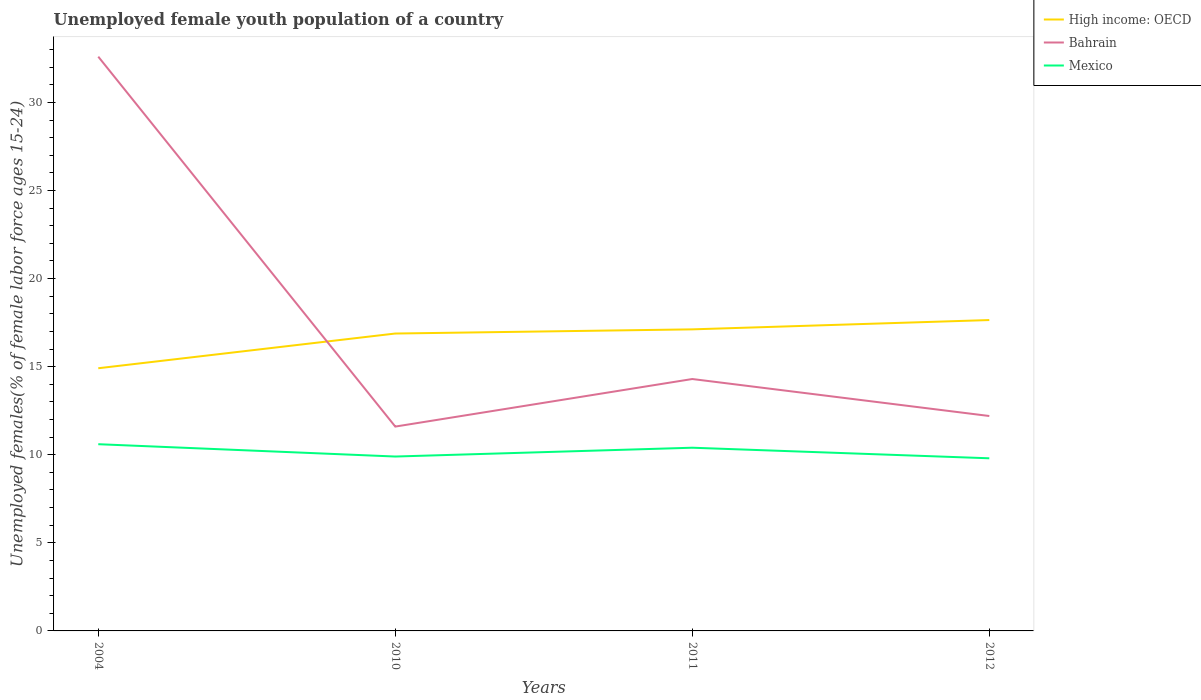How many different coloured lines are there?
Provide a short and direct response. 3. Across all years, what is the maximum percentage of unemployed female youth population in Bahrain?
Provide a short and direct response. 11.6. What is the total percentage of unemployed female youth population in Mexico in the graph?
Your response must be concise. 0.6. What is the difference between the highest and the second highest percentage of unemployed female youth population in High income: OECD?
Offer a terse response. 2.74. What is the difference between the highest and the lowest percentage of unemployed female youth population in High income: OECD?
Your answer should be very brief. 3. Is the percentage of unemployed female youth population in Bahrain strictly greater than the percentage of unemployed female youth population in High income: OECD over the years?
Ensure brevity in your answer.  No. How many years are there in the graph?
Your answer should be compact. 4. How many legend labels are there?
Keep it short and to the point. 3. What is the title of the graph?
Your answer should be very brief. Unemployed female youth population of a country. Does "Argentina" appear as one of the legend labels in the graph?
Your answer should be compact. No. What is the label or title of the Y-axis?
Offer a very short reply. Unemployed females(% of female labor force ages 15-24). What is the Unemployed females(% of female labor force ages 15-24) of High income: OECD in 2004?
Keep it short and to the point. 14.91. What is the Unemployed females(% of female labor force ages 15-24) of Bahrain in 2004?
Your answer should be very brief. 32.6. What is the Unemployed females(% of female labor force ages 15-24) in Mexico in 2004?
Make the answer very short. 10.6. What is the Unemployed females(% of female labor force ages 15-24) of High income: OECD in 2010?
Provide a succinct answer. 16.88. What is the Unemployed females(% of female labor force ages 15-24) in Bahrain in 2010?
Provide a succinct answer. 11.6. What is the Unemployed females(% of female labor force ages 15-24) of Mexico in 2010?
Keep it short and to the point. 9.9. What is the Unemployed females(% of female labor force ages 15-24) of High income: OECD in 2011?
Ensure brevity in your answer.  17.12. What is the Unemployed females(% of female labor force ages 15-24) of Bahrain in 2011?
Provide a short and direct response. 14.3. What is the Unemployed females(% of female labor force ages 15-24) in Mexico in 2011?
Make the answer very short. 10.4. What is the Unemployed females(% of female labor force ages 15-24) of High income: OECD in 2012?
Give a very brief answer. 17.65. What is the Unemployed females(% of female labor force ages 15-24) in Bahrain in 2012?
Provide a succinct answer. 12.2. What is the Unemployed females(% of female labor force ages 15-24) of Mexico in 2012?
Your response must be concise. 9.8. Across all years, what is the maximum Unemployed females(% of female labor force ages 15-24) of High income: OECD?
Your answer should be compact. 17.65. Across all years, what is the maximum Unemployed females(% of female labor force ages 15-24) in Bahrain?
Your answer should be very brief. 32.6. Across all years, what is the maximum Unemployed females(% of female labor force ages 15-24) in Mexico?
Your response must be concise. 10.6. Across all years, what is the minimum Unemployed females(% of female labor force ages 15-24) of High income: OECD?
Give a very brief answer. 14.91. Across all years, what is the minimum Unemployed females(% of female labor force ages 15-24) in Bahrain?
Provide a short and direct response. 11.6. Across all years, what is the minimum Unemployed females(% of female labor force ages 15-24) in Mexico?
Offer a very short reply. 9.8. What is the total Unemployed females(% of female labor force ages 15-24) in High income: OECD in the graph?
Give a very brief answer. 66.56. What is the total Unemployed females(% of female labor force ages 15-24) of Bahrain in the graph?
Your answer should be very brief. 70.7. What is the total Unemployed females(% of female labor force ages 15-24) of Mexico in the graph?
Make the answer very short. 40.7. What is the difference between the Unemployed females(% of female labor force ages 15-24) in High income: OECD in 2004 and that in 2010?
Your answer should be very brief. -1.97. What is the difference between the Unemployed females(% of female labor force ages 15-24) of Bahrain in 2004 and that in 2010?
Your response must be concise. 21. What is the difference between the Unemployed females(% of female labor force ages 15-24) in High income: OECD in 2004 and that in 2011?
Provide a succinct answer. -2.21. What is the difference between the Unemployed females(% of female labor force ages 15-24) of Bahrain in 2004 and that in 2011?
Ensure brevity in your answer.  18.3. What is the difference between the Unemployed females(% of female labor force ages 15-24) of High income: OECD in 2004 and that in 2012?
Your answer should be very brief. -2.74. What is the difference between the Unemployed females(% of female labor force ages 15-24) in Bahrain in 2004 and that in 2012?
Offer a very short reply. 20.4. What is the difference between the Unemployed females(% of female labor force ages 15-24) of High income: OECD in 2010 and that in 2011?
Your response must be concise. -0.24. What is the difference between the Unemployed females(% of female labor force ages 15-24) of Bahrain in 2010 and that in 2011?
Keep it short and to the point. -2.7. What is the difference between the Unemployed females(% of female labor force ages 15-24) in Mexico in 2010 and that in 2011?
Your answer should be compact. -0.5. What is the difference between the Unemployed females(% of female labor force ages 15-24) of High income: OECD in 2010 and that in 2012?
Make the answer very short. -0.77. What is the difference between the Unemployed females(% of female labor force ages 15-24) in Mexico in 2010 and that in 2012?
Offer a terse response. 0.1. What is the difference between the Unemployed females(% of female labor force ages 15-24) of High income: OECD in 2011 and that in 2012?
Provide a succinct answer. -0.53. What is the difference between the Unemployed females(% of female labor force ages 15-24) of Bahrain in 2011 and that in 2012?
Ensure brevity in your answer.  2.1. What is the difference between the Unemployed females(% of female labor force ages 15-24) in Mexico in 2011 and that in 2012?
Give a very brief answer. 0.6. What is the difference between the Unemployed females(% of female labor force ages 15-24) of High income: OECD in 2004 and the Unemployed females(% of female labor force ages 15-24) of Bahrain in 2010?
Your response must be concise. 3.31. What is the difference between the Unemployed females(% of female labor force ages 15-24) in High income: OECD in 2004 and the Unemployed females(% of female labor force ages 15-24) in Mexico in 2010?
Provide a short and direct response. 5.01. What is the difference between the Unemployed females(% of female labor force ages 15-24) of Bahrain in 2004 and the Unemployed females(% of female labor force ages 15-24) of Mexico in 2010?
Provide a short and direct response. 22.7. What is the difference between the Unemployed females(% of female labor force ages 15-24) of High income: OECD in 2004 and the Unemployed females(% of female labor force ages 15-24) of Bahrain in 2011?
Your answer should be very brief. 0.61. What is the difference between the Unemployed females(% of female labor force ages 15-24) of High income: OECD in 2004 and the Unemployed females(% of female labor force ages 15-24) of Mexico in 2011?
Provide a succinct answer. 4.51. What is the difference between the Unemployed females(% of female labor force ages 15-24) of Bahrain in 2004 and the Unemployed females(% of female labor force ages 15-24) of Mexico in 2011?
Make the answer very short. 22.2. What is the difference between the Unemployed females(% of female labor force ages 15-24) in High income: OECD in 2004 and the Unemployed females(% of female labor force ages 15-24) in Bahrain in 2012?
Your answer should be very brief. 2.71. What is the difference between the Unemployed females(% of female labor force ages 15-24) in High income: OECD in 2004 and the Unemployed females(% of female labor force ages 15-24) in Mexico in 2012?
Ensure brevity in your answer.  5.11. What is the difference between the Unemployed females(% of female labor force ages 15-24) of Bahrain in 2004 and the Unemployed females(% of female labor force ages 15-24) of Mexico in 2012?
Ensure brevity in your answer.  22.8. What is the difference between the Unemployed females(% of female labor force ages 15-24) of High income: OECD in 2010 and the Unemployed females(% of female labor force ages 15-24) of Bahrain in 2011?
Provide a succinct answer. 2.58. What is the difference between the Unemployed females(% of female labor force ages 15-24) in High income: OECD in 2010 and the Unemployed females(% of female labor force ages 15-24) in Mexico in 2011?
Ensure brevity in your answer.  6.48. What is the difference between the Unemployed females(% of female labor force ages 15-24) of Bahrain in 2010 and the Unemployed females(% of female labor force ages 15-24) of Mexico in 2011?
Keep it short and to the point. 1.2. What is the difference between the Unemployed females(% of female labor force ages 15-24) of High income: OECD in 2010 and the Unemployed females(% of female labor force ages 15-24) of Bahrain in 2012?
Ensure brevity in your answer.  4.68. What is the difference between the Unemployed females(% of female labor force ages 15-24) in High income: OECD in 2010 and the Unemployed females(% of female labor force ages 15-24) in Mexico in 2012?
Your answer should be very brief. 7.08. What is the difference between the Unemployed females(% of female labor force ages 15-24) in High income: OECD in 2011 and the Unemployed females(% of female labor force ages 15-24) in Bahrain in 2012?
Provide a succinct answer. 4.92. What is the difference between the Unemployed females(% of female labor force ages 15-24) in High income: OECD in 2011 and the Unemployed females(% of female labor force ages 15-24) in Mexico in 2012?
Keep it short and to the point. 7.32. What is the average Unemployed females(% of female labor force ages 15-24) of High income: OECD per year?
Your answer should be very brief. 16.64. What is the average Unemployed females(% of female labor force ages 15-24) in Bahrain per year?
Give a very brief answer. 17.68. What is the average Unemployed females(% of female labor force ages 15-24) in Mexico per year?
Provide a short and direct response. 10.18. In the year 2004, what is the difference between the Unemployed females(% of female labor force ages 15-24) of High income: OECD and Unemployed females(% of female labor force ages 15-24) of Bahrain?
Ensure brevity in your answer.  -17.69. In the year 2004, what is the difference between the Unemployed females(% of female labor force ages 15-24) of High income: OECD and Unemployed females(% of female labor force ages 15-24) of Mexico?
Provide a short and direct response. 4.31. In the year 2004, what is the difference between the Unemployed females(% of female labor force ages 15-24) of Bahrain and Unemployed females(% of female labor force ages 15-24) of Mexico?
Make the answer very short. 22. In the year 2010, what is the difference between the Unemployed females(% of female labor force ages 15-24) in High income: OECD and Unemployed females(% of female labor force ages 15-24) in Bahrain?
Keep it short and to the point. 5.28. In the year 2010, what is the difference between the Unemployed females(% of female labor force ages 15-24) of High income: OECD and Unemployed females(% of female labor force ages 15-24) of Mexico?
Offer a very short reply. 6.98. In the year 2010, what is the difference between the Unemployed females(% of female labor force ages 15-24) in Bahrain and Unemployed females(% of female labor force ages 15-24) in Mexico?
Provide a succinct answer. 1.7. In the year 2011, what is the difference between the Unemployed females(% of female labor force ages 15-24) of High income: OECD and Unemployed females(% of female labor force ages 15-24) of Bahrain?
Offer a terse response. 2.82. In the year 2011, what is the difference between the Unemployed females(% of female labor force ages 15-24) in High income: OECD and Unemployed females(% of female labor force ages 15-24) in Mexico?
Keep it short and to the point. 6.72. In the year 2012, what is the difference between the Unemployed females(% of female labor force ages 15-24) in High income: OECD and Unemployed females(% of female labor force ages 15-24) in Bahrain?
Keep it short and to the point. 5.45. In the year 2012, what is the difference between the Unemployed females(% of female labor force ages 15-24) in High income: OECD and Unemployed females(% of female labor force ages 15-24) in Mexico?
Provide a succinct answer. 7.85. In the year 2012, what is the difference between the Unemployed females(% of female labor force ages 15-24) of Bahrain and Unemployed females(% of female labor force ages 15-24) of Mexico?
Provide a succinct answer. 2.4. What is the ratio of the Unemployed females(% of female labor force ages 15-24) in High income: OECD in 2004 to that in 2010?
Give a very brief answer. 0.88. What is the ratio of the Unemployed females(% of female labor force ages 15-24) of Bahrain in 2004 to that in 2010?
Provide a short and direct response. 2.81. What is the ratio of the Unemployed females(% of female labor force ages 15-24) of Mexico in 2004 to that in 2010?
Provide a short and direct response. 1.07. What is the ratio of the Unemployed females(% of female labor force ages 15-24) in High income: OECD in 2004 to that in 2011?
Offer a very short reply. 0.87. What is the ratio of the Unemployed females(% of female labor force ages 15-24) of Bahrain in 2004 to that in 2011?
Give a very brief answer. 2.28. What is the ratio of the Unemployed females(% of female labor force ages 15-24) of Mexico in 2004 to that in 2011?
Your answer should be very brief. 1.02. What is the ratio of the Unemployed females(% of female labor force ages 15-24) of High income: OECD in 2004 to that in 2012?
Make the answer very short. 0.84. What is the ratio of the Unemployed females(% of female labor force ages 15-24) in Bahrain in 2004 to that in 2012?
Provide a succinct answer. 2.67. What is the ratio of the Unemployed females(% of female labor force ages 15-24) of Mexico in 2004 to that in 2012?
Ensure brevity in your answer.  1.08. What is the ratio of the Unemployed females(% of female labor force ages 15-24) in High income: OECD in 2010 to that in 2011?
Provide a succinct answer. 0.99. What is the ratio of the Unemployed females(% of female labor force ages 15-24) of Bahrain in 2010 to that in 2011?
Provide a succinct answer. 0.81. What is the ratio of the Unemployed females(% of female labor force ages 15-24) of Mexico in 2010 to that in 2011?
Provide a succinct answer. 0.95. What is the ratio of the Unemployed females(% of female labor force ages 15-24) in High income: OECD in 2010 to that in 2012?
Keep it short and to the point. 0.96. What is the ratio of the Unemployed females(% of female labor force ages 15-24) of Bahrain in 2010 to that in 2012?
Keep it short and to the point. 0.95. What is the ratio of the Unemployed females(% of female labor force ages 15-24) of Mexico in 2010 to that in 2012?
Offer a very short reply. 1.01. What is the ratio of the Unemployed females(% of female labor force ages 15-24) of Bahrain in 2011 to that in 2012?
Your answer should be very brief. 1.17. What is the ratio of the Unemployed females(% of female labor force ages 15-24) in Mexico in 2011 to that in 2012?
Your answer should be very brief. 1.06. What is the difference between the highest and the second highest Unemployed females(% of female labor force ages 15-24) of High income: OECD?
Ensure brevity in your answer.  0.53. What is the difference between the highest and the lowest Unemployed females(% of female labor force ages 15-24) of High income: OECD?
Offer a terse response. 2.74. 